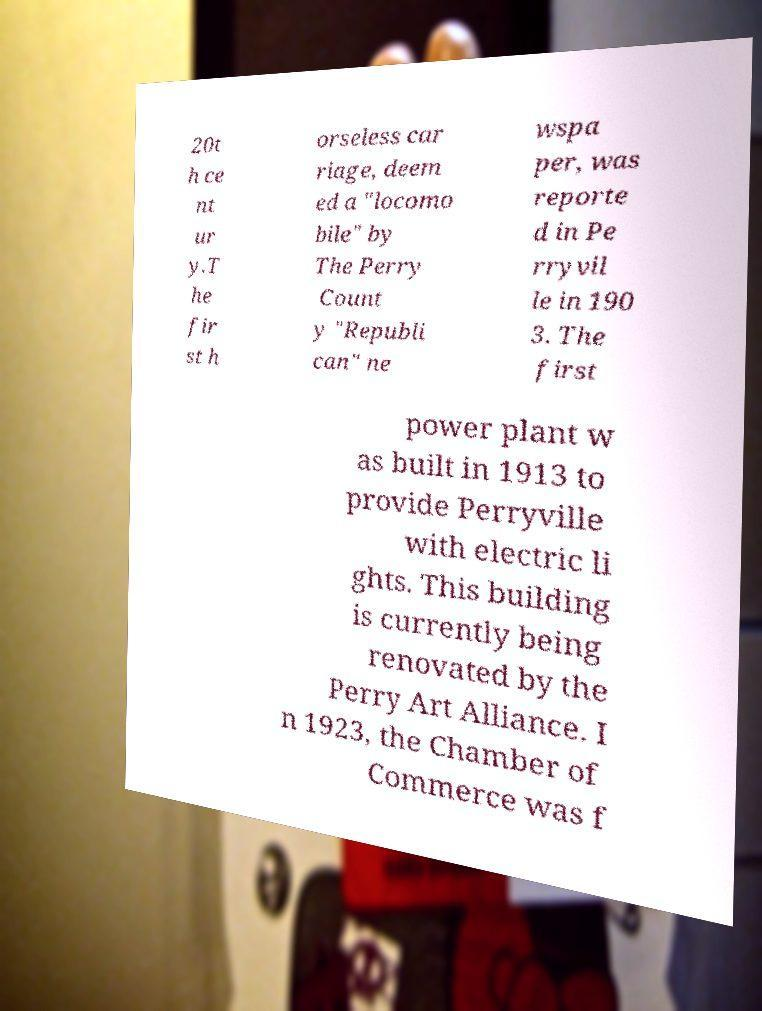Could you extract and type out the text from this image? 20t h ce nt ur y.T he fir st h orseless car riage, deem ed a "locomo bile" by The Perry Count y "Republi can" ne wspa per, was reporte d in Pe rryvil le in 190 3. The first power plant w as built in 1913 to provide Perryville with electric li ghts. This building is currently being renovated by the Perry Art Alliance. I n 1923, the Chamber of Commerce was f 